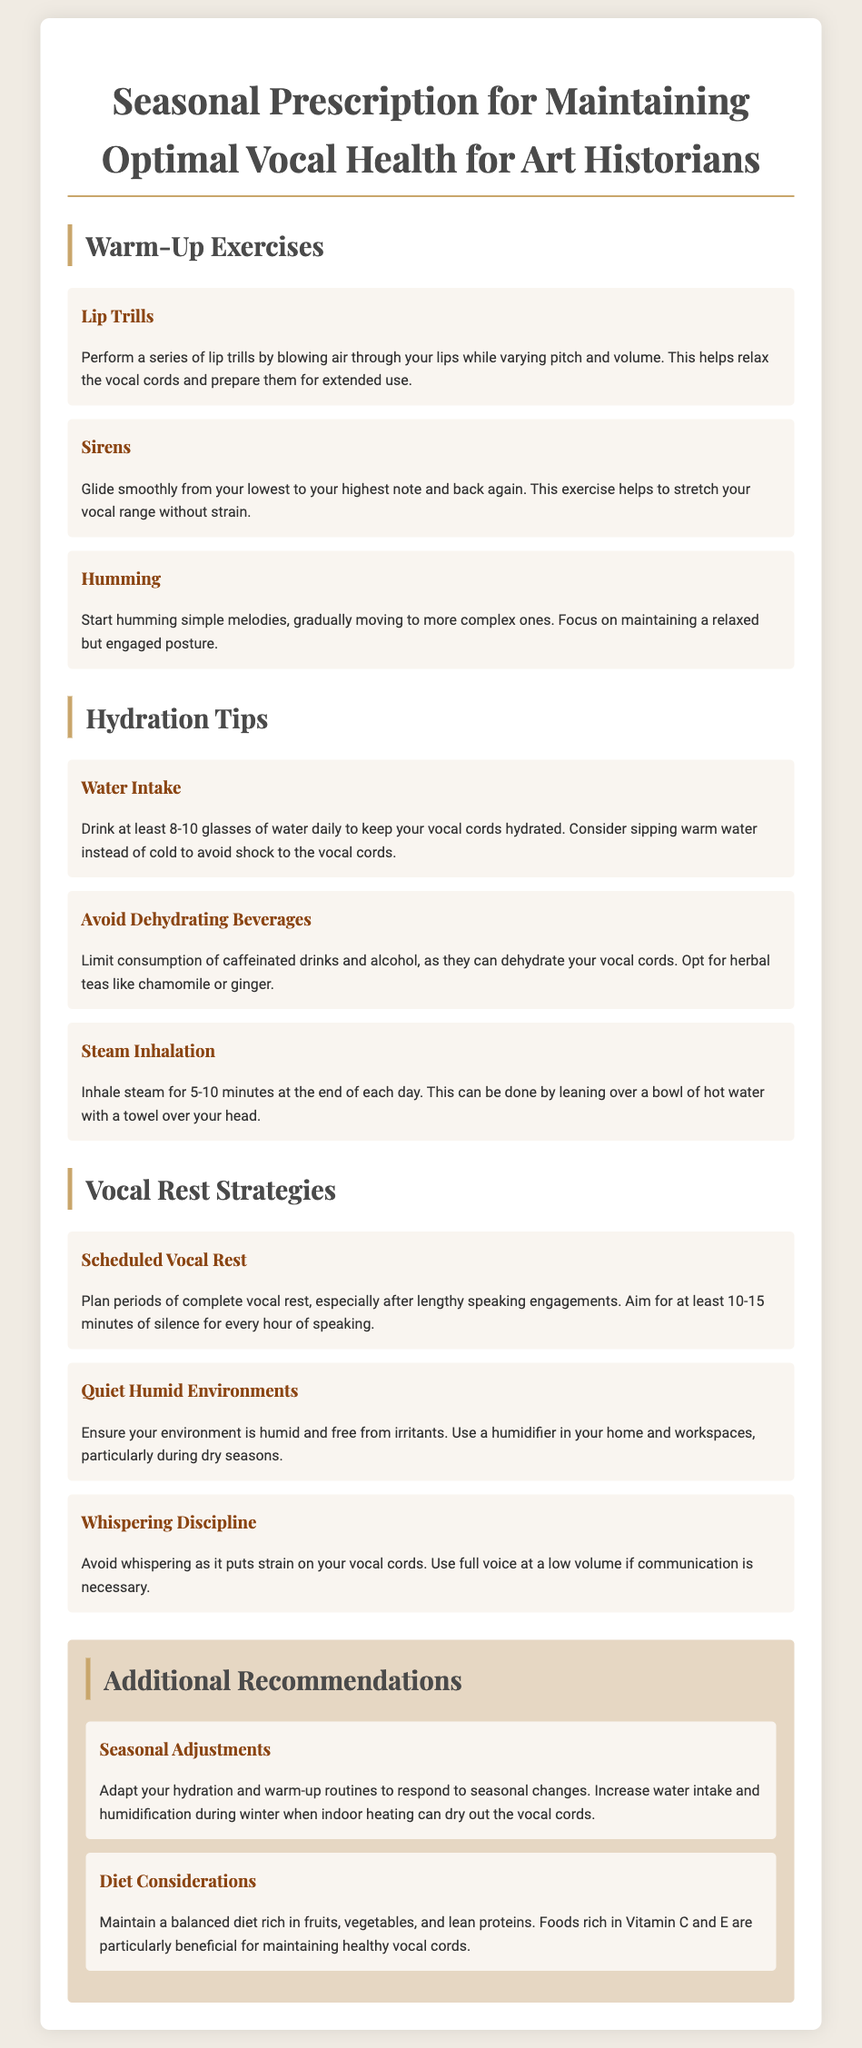What are lip trills? Lip trills are a warm-up exercise that involves blowing air through the lips while varying pitch and volume.
Answer: Blowing air through lips How many glasses of water should be consumed daily? The document states that at least 8-10 glasses of water should be consumed daily for vocal cord hydration.
Answer: 8-10 glasses What is a recommended duration for scheduled vocal rest after speaking? The document suggests planning for at least 10-15 minutes of silence for every hour of speaking.
Answer: 10-15 minutes What is one benefit of steam inhalation? Steam inhalation helps by keeping the vocal cords hydrated, particularly at the end of the day.
Answer: Keeping vocal cords hydrated What should be avoided to prevent vocal strain when communicating? Whispering should be avoided as it puts strain on the vocal cords; using full voice at a low volume is recommended.
Answer: Whispering What type of dietary foods are beneficial for vocal health? The document notes that foods rich in Vitamin C and E are particularly beneficial for maintaining healthy vocal cords.
Answer: Vitamin C and E rich foods What should be done to adapt hydration routines seasonally? The document advises increasing water intake and humidification during winter when indoor heating can dry out vocal cords.
Answer: Increase water intake What is one strategy mentioned for a humid environment? Using a humidifier in homes and workspaces is suggested to ensure the environment is humid and free from irritants.
Answer: Use a humidifier How many warm-up exercises are listed in the document? The document lists three warm-up exercises: lip trills, sirens, and humming.
Answer: Three 